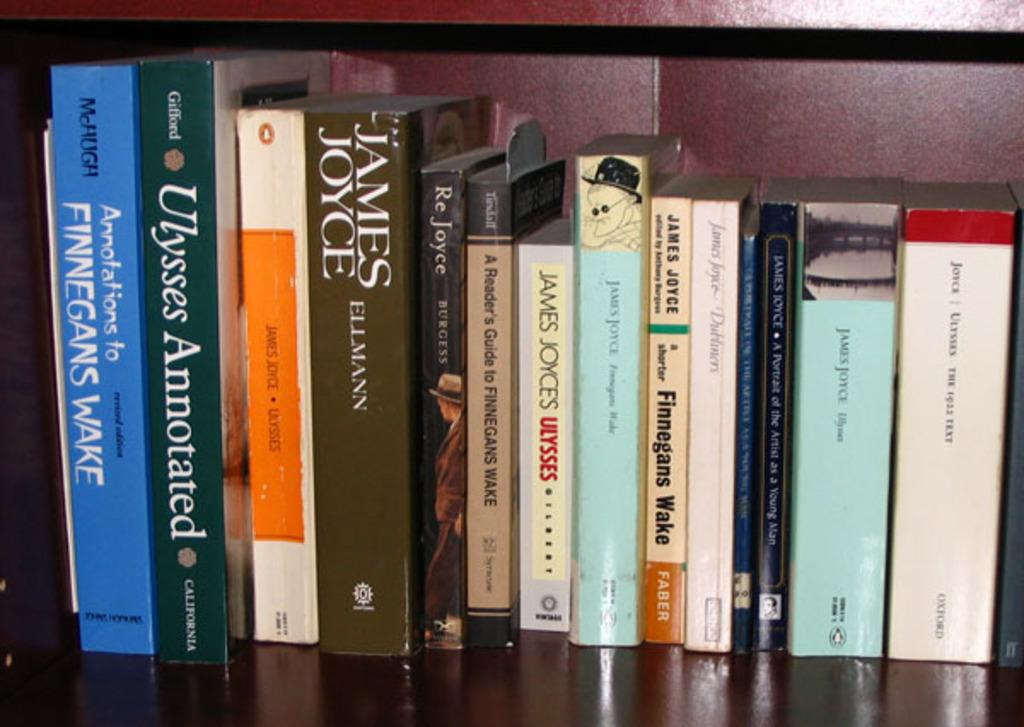<image>
Relay a brief, clear account of the picture shown. A collection of books with their spine facing out, one of them by James Joyce. 